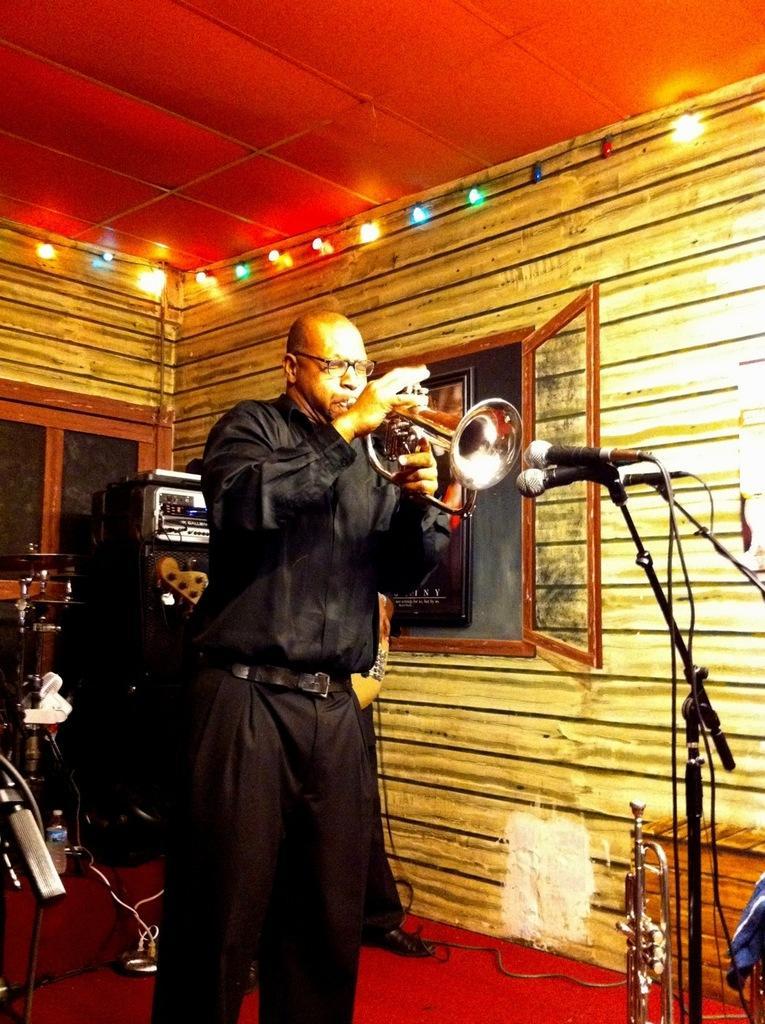Could you give a brief overview of what you see in this image? This picture shows a man standing and holding a trumpet in his hand and we see couple of microphones and few lights and we see a window and men wore spectacles on his pace and he wore a black color dress and we see another human on the back. 